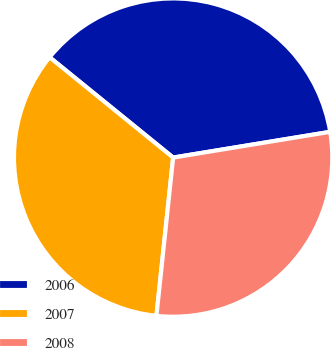Convert chart to OTSL. <chart><loc_0><loc_0><loc_500><loc_500><pie_chart><fcel>2006<fcel>2007<fcel>2008<nl><fcel>36.56%<fcel>34.18%<fcel>29.26%<nl></chart> 